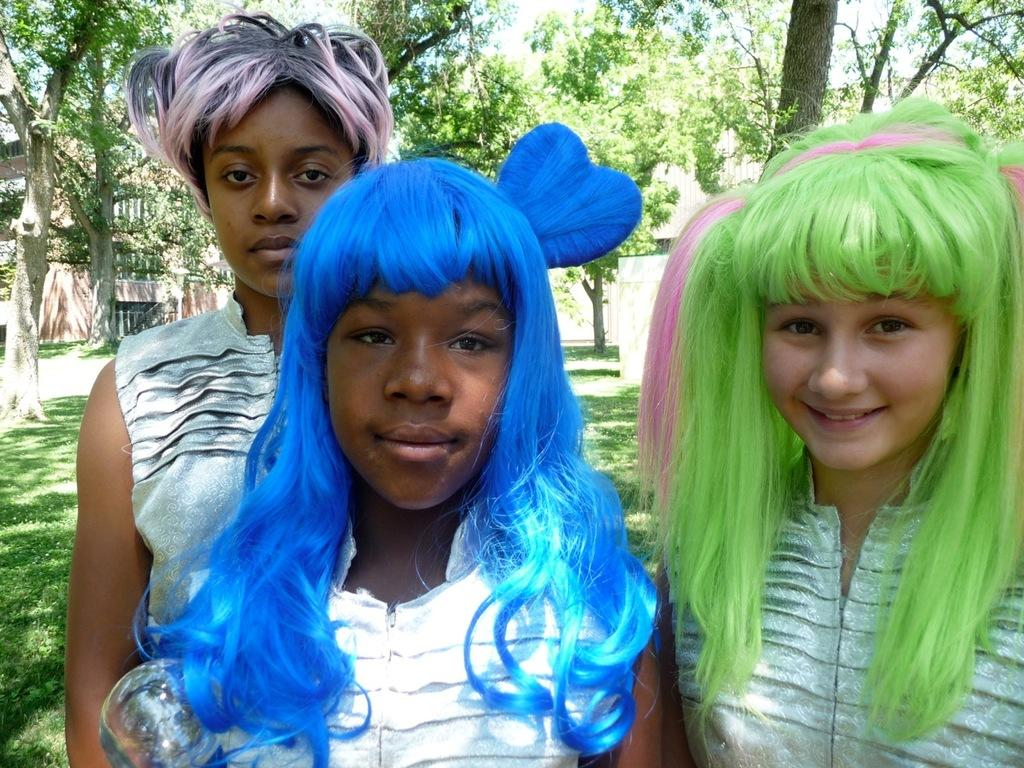How many women are in the image? There are three women in the image. What are the women wearing? The women are wearing dresses. What are the women doing in the image? The women are standing. What can be seen in the background of the image? There is a group of trees and a building in the background of the image. What type of mask is the woman on the left wearing in the image? There is no mask present in the image; the women are wearing dresses. Where is the stove located in the image? There is no stove present in the image. 